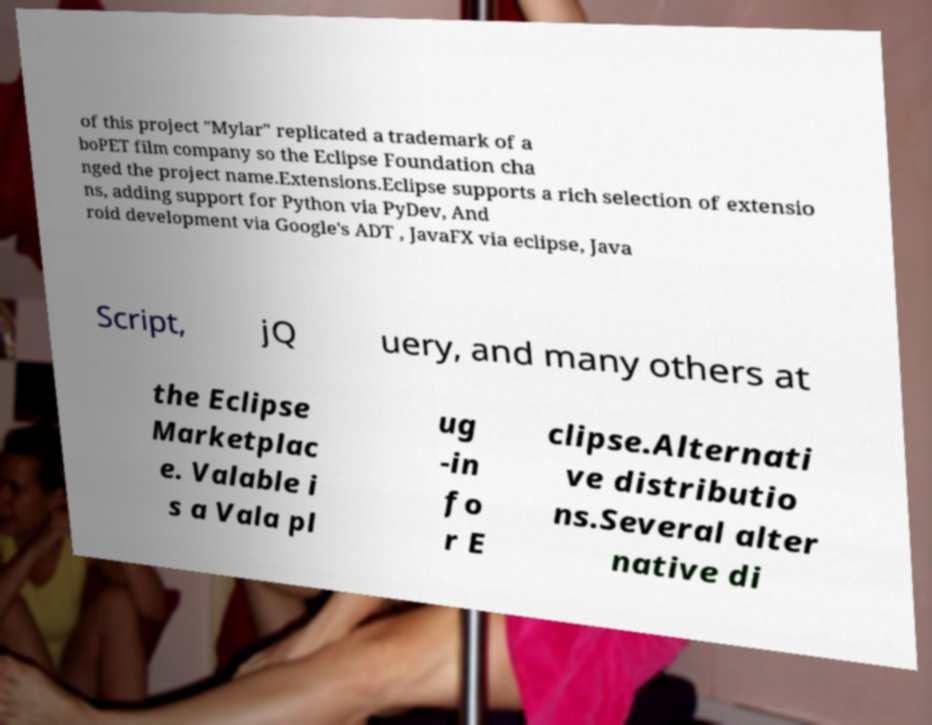Could you extract and type out the text from this image? of this project "Mylar" replicated a trademark of a boPET film company so the Eclipse Foundation cha nged the project name.Extensions.Eclipse supports a rich selection of extensio ns, adding support for Python via PyDev, And roid development via Google's ADT , JavaFX via eclipse, Java Script, jQ uery, and many others at the Eclipse Marketplac e. Valable i s a Vala pl ug -in fo r E clipse.Alternati ve distributio ns.Several alter native di 